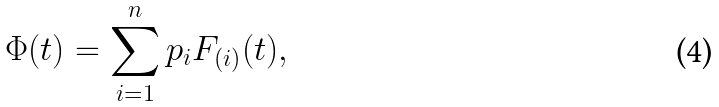Convert formula to latex. <formula><loc_0><loc_0><loc_500><loc_500>\Phi ( t ) = \sum _ { i = 1 } ^ { n } p _ { i } F _ { ( i ) } ( t ) ,</formula> 